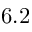<formula> <loc_0><loc_0><loc_500><loc_500>6 . 2</formula> 